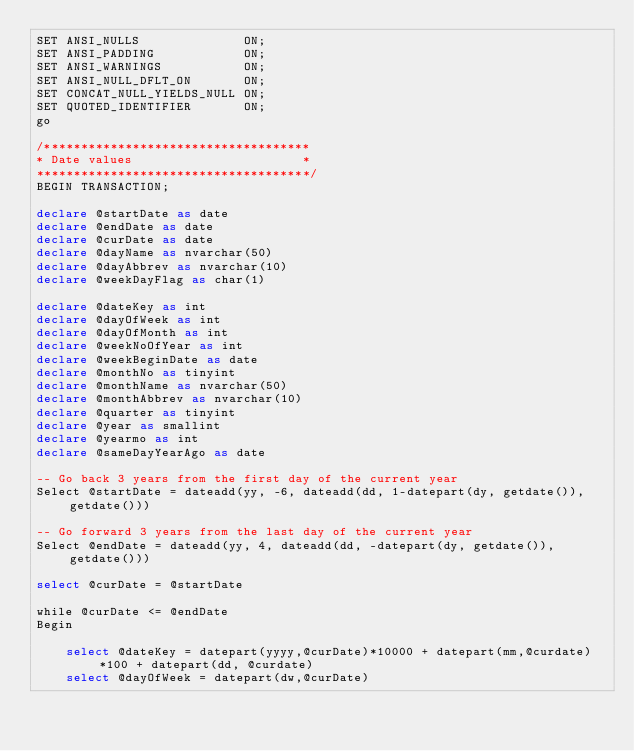<code> <loc_0><loc_0><loc_500><loc_500><_SQL_>SET ANSI_NULLS              ON;
SET ANSI_PADDING            ON;
SET ANSI_WARNINGS           ON;
SET ANSI_NULL_DFLT_ON       ON;
SET CONCAT_NULL_YIELDS_NULL ON;
SET QUOTED_IDENTIFIER       ON;
go

/************************************
* Date values                       *
*************************************/
BEGIN TRANSACTION;

declare @startDate as date
declare @endDate as date
declare @curDate as date
declare @dayName as nvarchar(50)
declare @dayAbbrev as nvarchar(10)
declare @weekDayFlag as char(1)

declare @dateKey as int
declare @dayOfWeek as int
declare @dayOfMonth as int
declare @weekNoOfYear as int
declare @weekBeginDate as date
declare @monthNo as tinyint
declare @monthName as nvarchar(50)
declare @monthAbbrev as nvarchar(10)
declare @quarter as tinyint
declare @year as smallint
declare @yearmo as int
declare @sameDayYearAgo as date

-- Go back 3 years from the first day of the current year
Select @startDate = dateadd(yy, -6, dateadd(dd, 1-datepart(dy, getdate()), getdate()))

-- Go forward 3 years from the last day of the current year
Select @endDate = dateadd(yy, 4, dateadd(dd, -datepart(dy, getdate()), getdate()))

select @curDate = @startDate

while @curDate <= @endDate
Begin

	select @dateKey = datepart(yyyy,@curDate)*10000 + datepart(mm,@curdate)*100 + datepart(dd, @curdate)
	select @dayOfWeek = datepart(dw,@curDate)</code> 